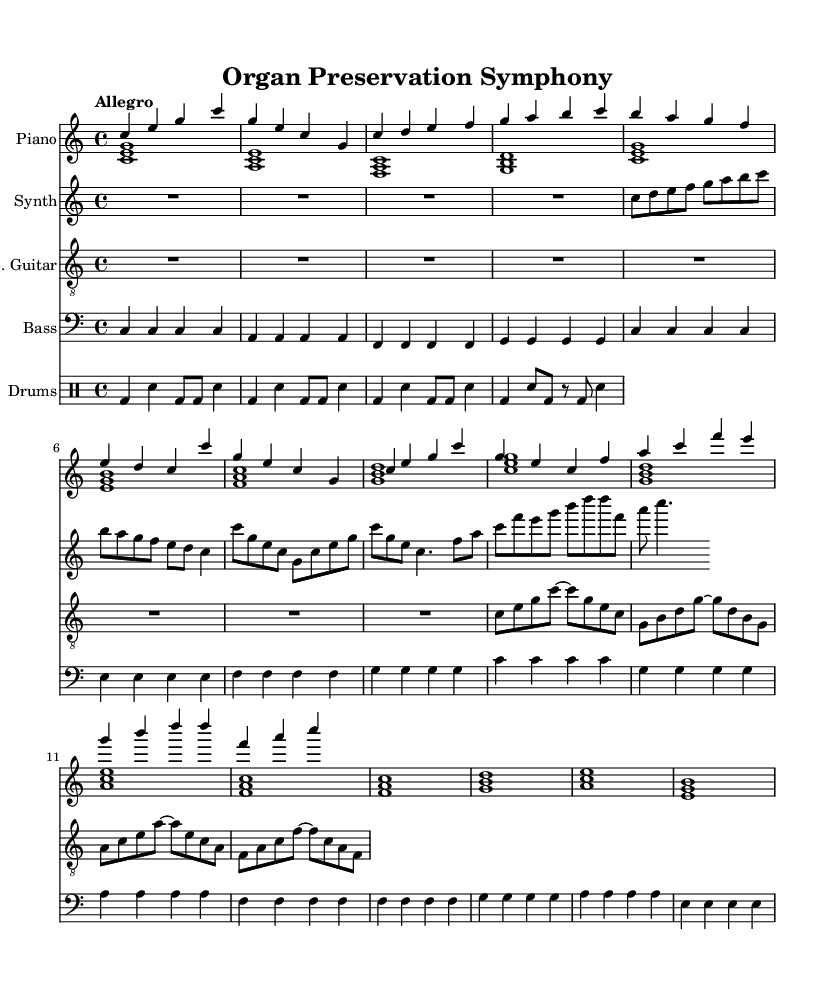What is the key signature of this music? The key signature is indicated at the beginning of the score. The presence of no sharps or flats designates this as C major.
Answer: C major What is the time signature of this music? The time signature is also noted at the start of the score, with a '4/4' symbol indicating four beats per measure.
Answer: 4/4 What is the tempo marking for this piece? The tempo is shown at the beginning of the score with the word 'Allegro,' which means a fast, lively tempo.
Answer: Allegro How many measures are in the Chorus section? By examining the sheet music, you can count the number of measures dedicated to the Chorus section, which appears twice, totaling four measures.
Answer: 4 What instruments are used in this piece? By reviewing the score, we note the presence of Piano, Synth, Electric Guitar, Bass, and Drums, listed in the order of their staves.
Answer: Piano, Synth, Electric Guitar, Bass, Drums How does the Bass Guitar part interact with the Piano? Analyzing both the Bass Guitar and Piano parts, we see that the Bass Guitar provides a rhythmic foundation that complements the harmonic structure played by the Piano.
Answer: Provides foundation What is the genre/style inferred from this composition? Considering the upbeat and lively tempo along with the use of synth and drums, this composition appears to fit into an upbeat, energetic instrumental style, often found in contemporary motivational music.
Answer: Upbeat instrumental 